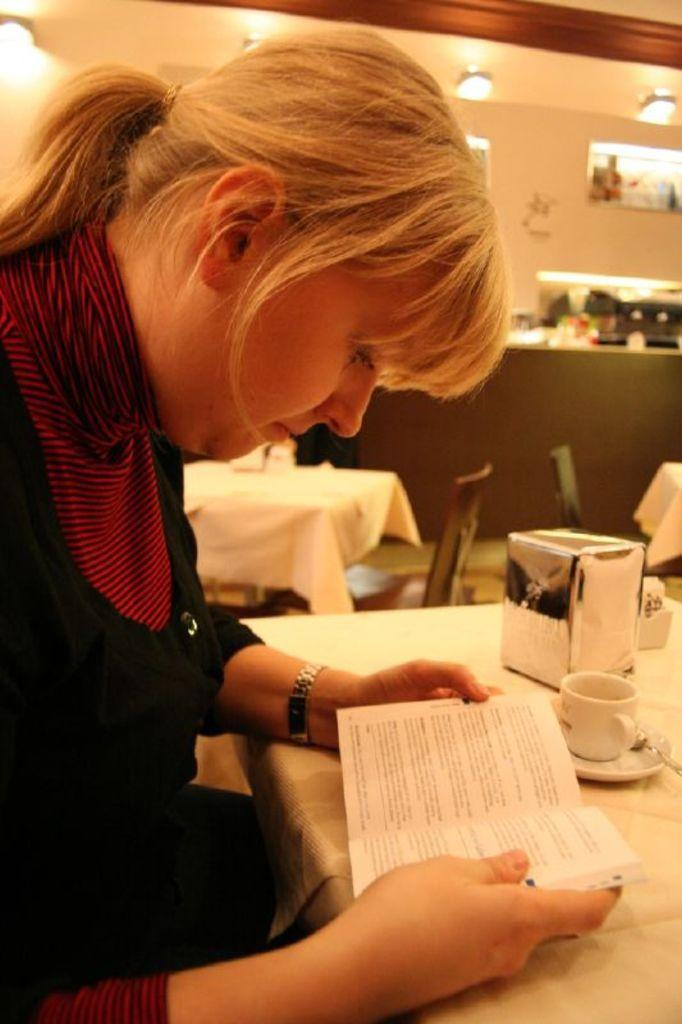Who is present in the image? There is a woman in the image. What is the woman doing in the image? The woman is sitting on a chair. What object can be seen on the table? There is a book, a cup, and a soccer ball on the table. Is the woman interacting with any of the objects on the table? Yes, the woman is holding the book. What type of flowers can be seen growing near the soccer ball in the image? There are no flowers present in the image; it features a woman sitting on a chair, a book, a cup, and a soccer ball on a table. 